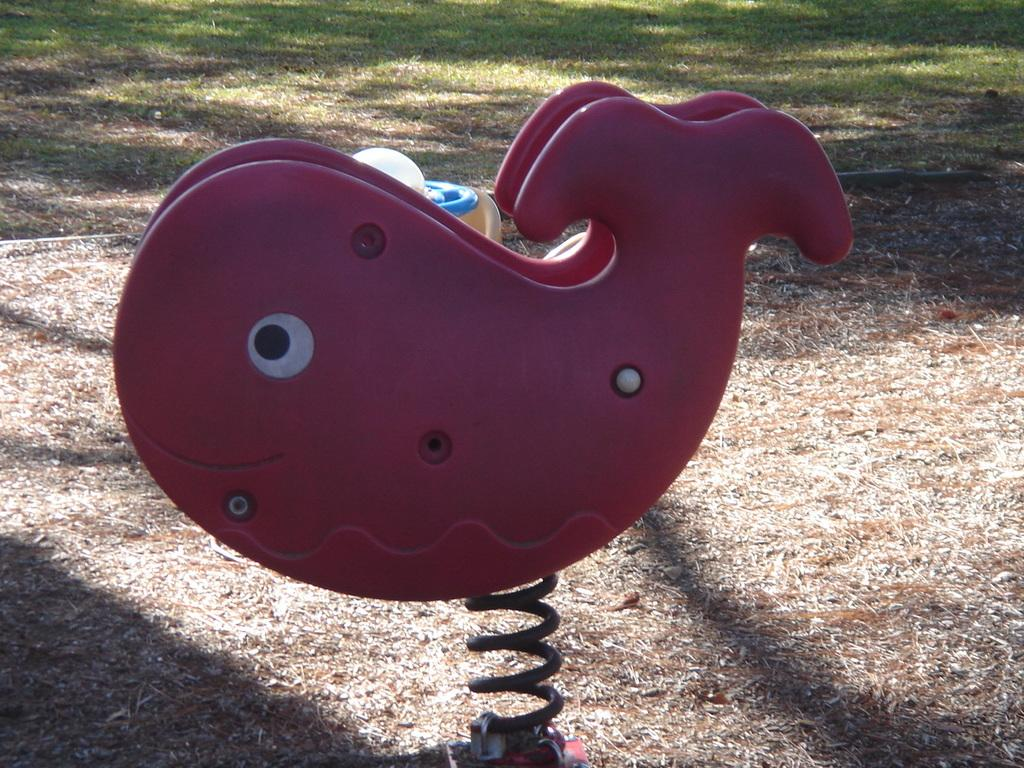What type of toy is present in the image? There is a toy fish in the image. What color is the toy fish? The toy fish is pink in color. What other object can be seen in the image? There is a spring in the image. What type of vegetation is visible in the background of the image? The background of the image includes grass. What color is the grass? The grass is green in color. Can you tell me how many goldfish are being kept in the image? There are no goldfish present in the image, only a toy fish. Is there a girl playing with the toy fish in the image? There is no girl present in the image; it only shows the toy fish, spring, and grass. 